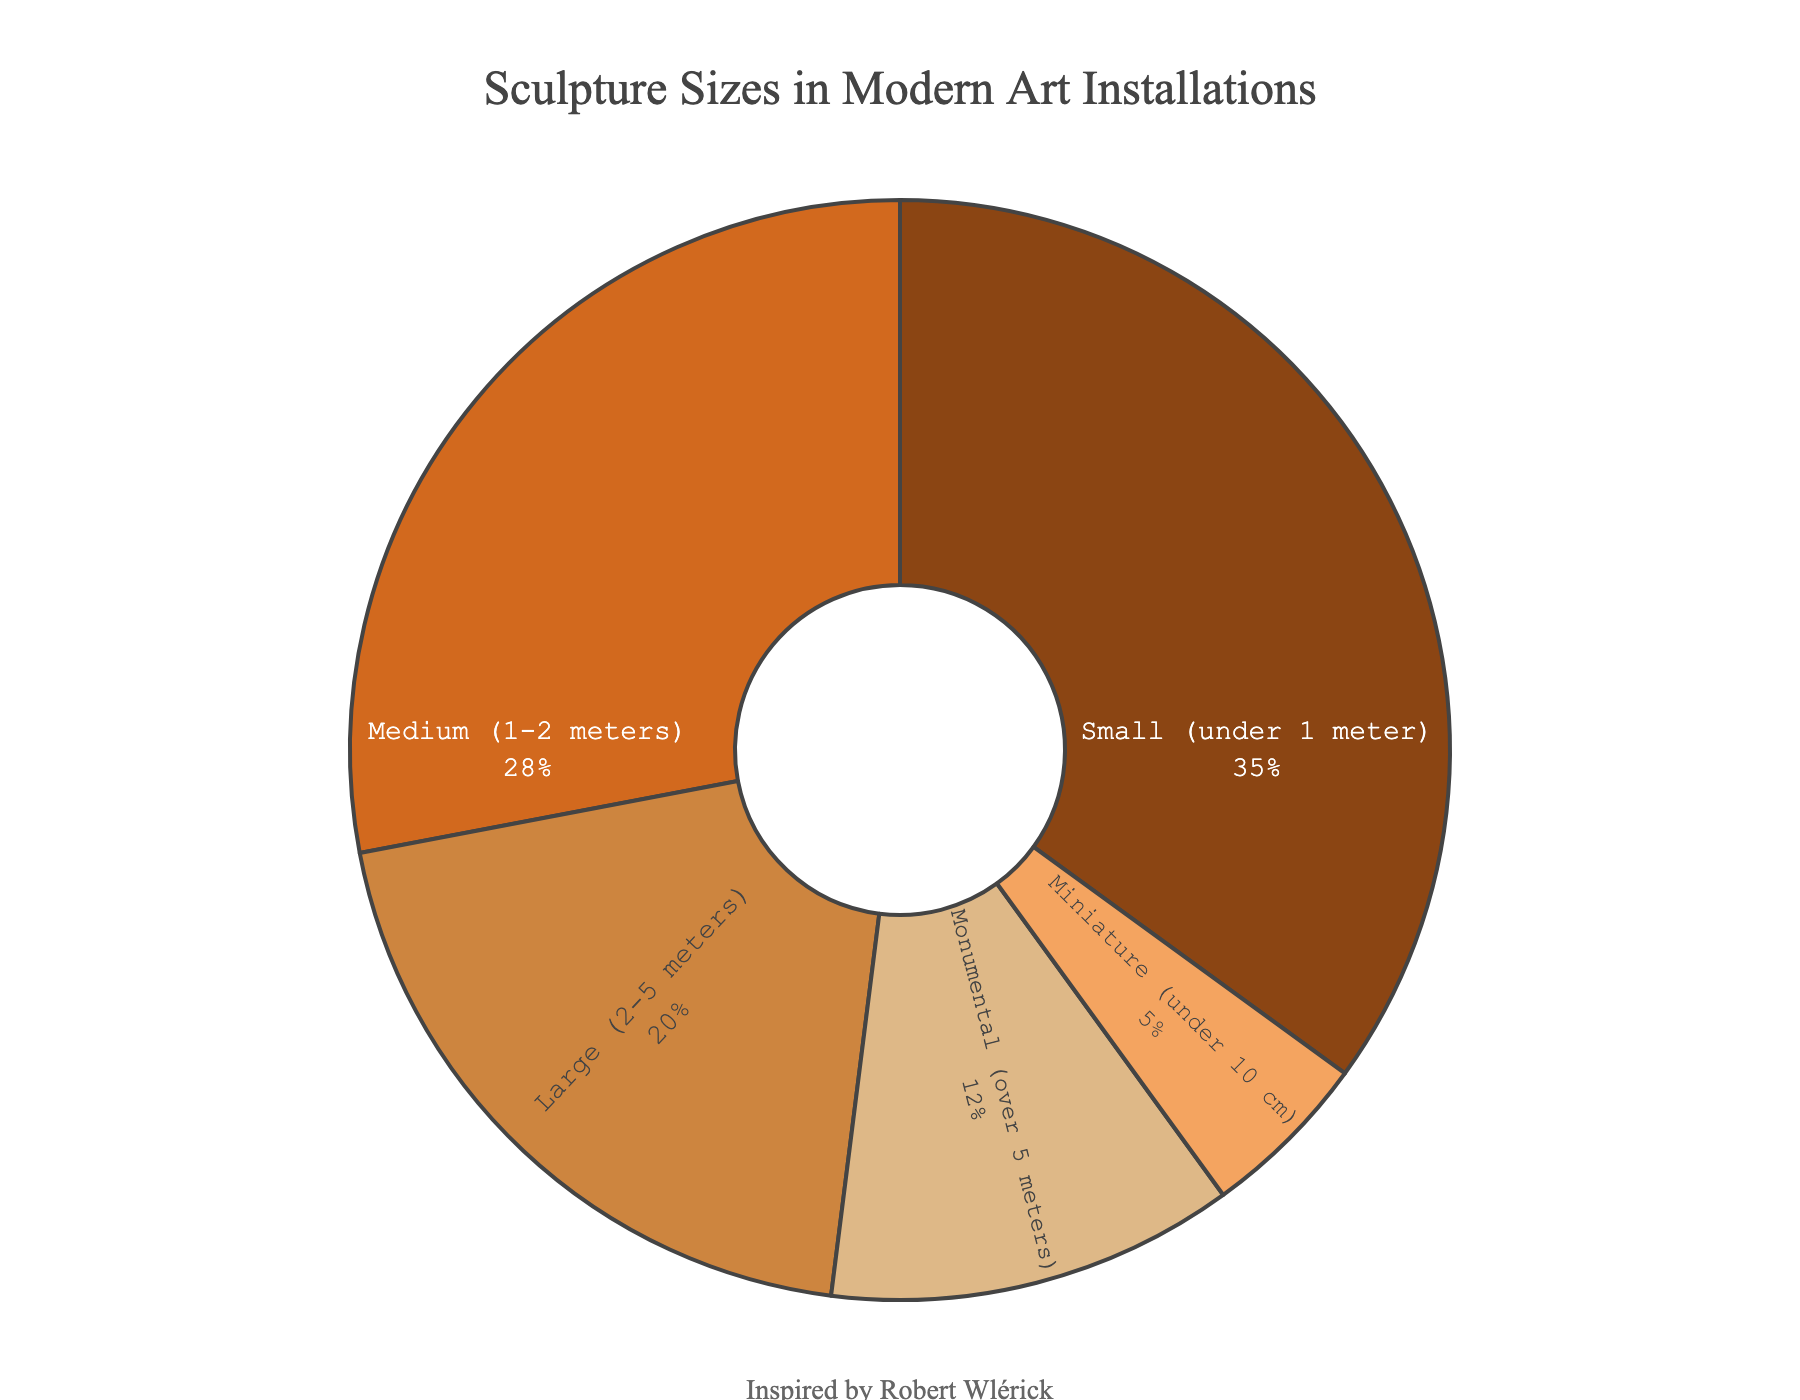What's the most common size of sculptures in modern art installations? Based on the pie chart, the segment labeled "Small (under 1 meter)" occupies the largest portion of the chart. This indicates that sculptures under 1 meter are the most common.
Answer: Small (under 1 meter) What percentage of sculptures are medium-sized (1-2 meters) or large (2-5 meters)? To find this, sum the percentages for the "Medium (1-2 meters)" and "Large (2-5 meters)" categories. Medium is 28% and Large is 20%, so the total is 28% + 20% = 48%.
Answer: 48% Are miniature sculptures (under 10 cm) more or less common than monumental sculptures (over 5 meters)? Compare the percentage values of the two categories. Miniature sculptures account for 5%, and monumental sculptures account for 12%. Since 5% is less than 12%, miniature sculptures are less common.
Answer: Less common What two sizes make up more than half of all sculptures in modern art installations? Identify the largest segments and see if their combined percentages exceed 50%. "Small (under 1 meter)" is 35%, and "Medium (1-2 meters)" is 28%. Combined, they make 35% + 28% = 63%, which is more than half.
Answer: Small and Medium How much more common are small sculptures (under 1 meter) compared to large sculptures (2-5 meters)? Subtract the percentage for large sculptures from the percentage for small sculptures. Small sculptures are 35%, and large sculptures are 20%, so 35% - 20% = 15%.
Answer: 15% more common What proportion of the sculptures are either small or miniature? Sum the percentages for the "Small (under 1 meter)" and "Miniature (under 10 cm)" categories. Small is 35%, and Miniature is 5%, so the total is 35% + 5% = 40%.
Answer: 40% Order the sculpture sizes from most to least common based on their percentages. By looking at the pie chart, arrange the sizes in descending order by their percentage values: Small (35%), Medium (28%), Large (20%), Monumental (12%), Miniature (5%).
Answer: Small, Medium, Large, Monumental, Miniature What is the least common size of sculptures? The smallest segment in the pie chart is labeled "Miniature (under 10 cm)," indicating it is the least common size category.
Answer: Miniature (under 10 cm) How does the percentage of large sculptures (2-5 meters) compare to the combined percentage of miniature and monumental sculptures? Find the combined percentage of miniature and monumental sculptures, then compare it with the percentage of large sculptures. Miniature is 5%, and monumental is 12%, so their combined percentage is 5% + 12% = 17%. Since large sculptures account for 20%, large sculptures make up a higher percentage.
Answer: Large sculptures are more common 